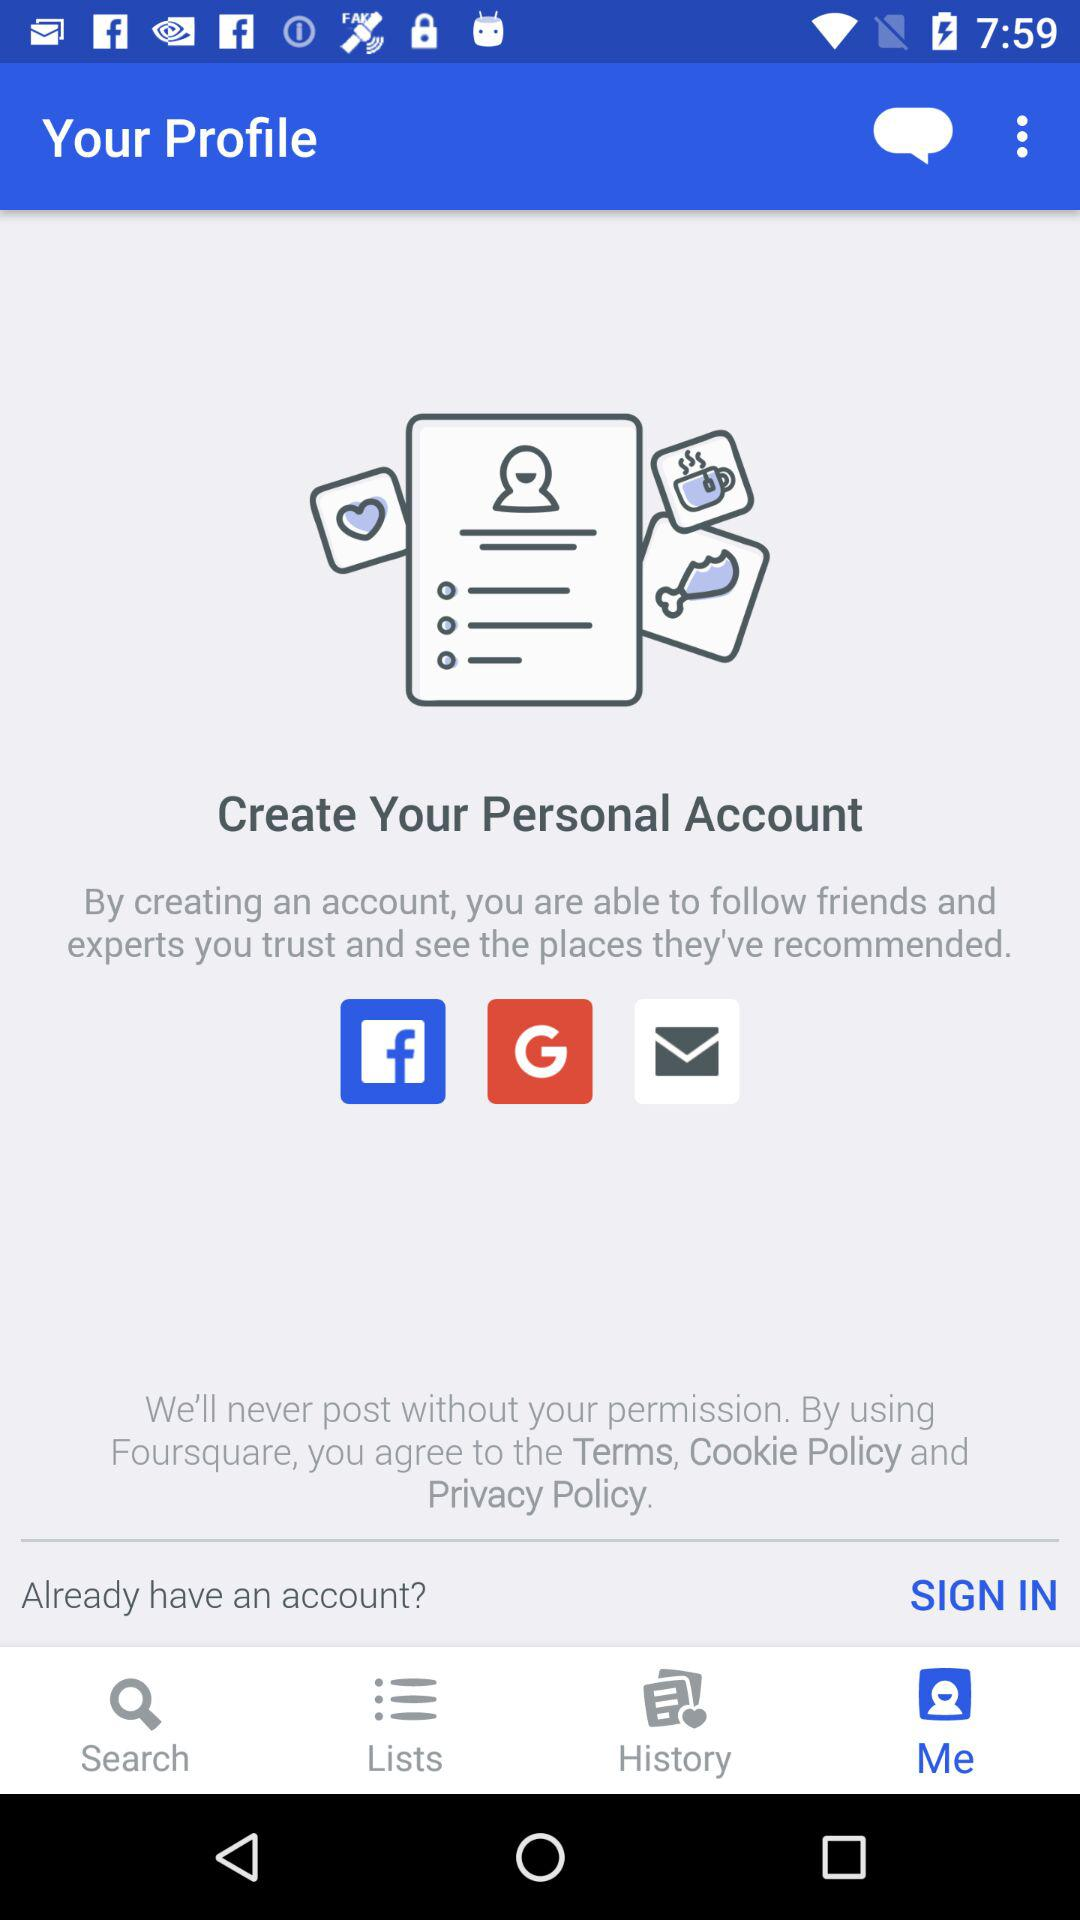Which are the different options to create the account? The different options are "Facebook", "Google" and "Email". 